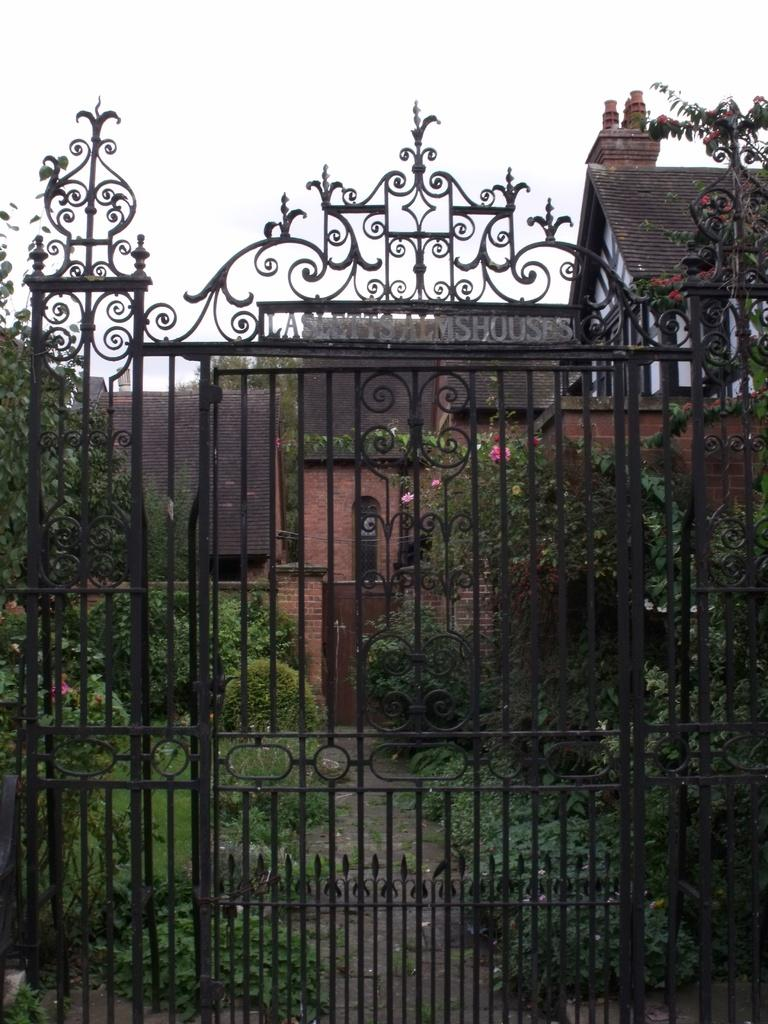What is the color of the gate in the image? The gate in the image is black. What can be seen on the land behind the gate? There are plants on the land behind the gate. What is visible in the background of the image? There is a building and the sky visible in the background of the image. How many bikes are parked in the room shown in the image? There is no room or bikes present in the image; it features a black gate with plants and a background with a building and the sky. 